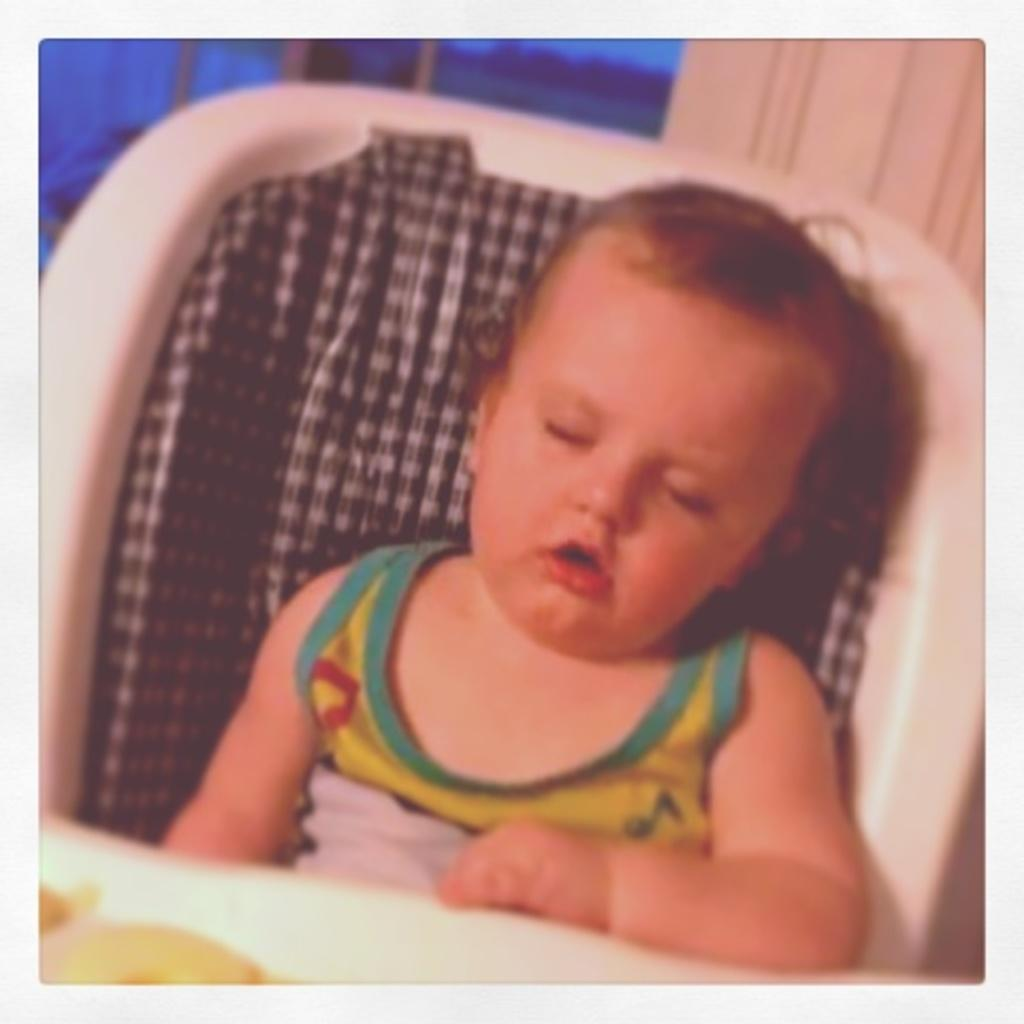What is the main subject of the image? There is a child in the image. What is the child doing in the image? The child is sitting on a chair. What word is the child saying in the image? There is no indication of the child speaking or saying a word in the image. How many clams are visible in the image? There are no clams present in the image. 